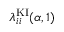<formula> <loc_0><loc_0><loc_500><loc_500>\lambda _ { i i } ^ { K I } ( \alpha , 1 )</formula> 